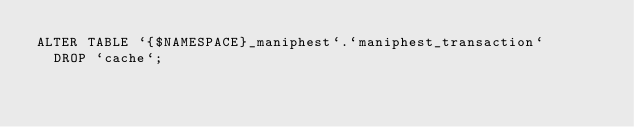<code> <loc_0><loc_0><loc_500><loc_500><_SQL_>ALTER TABLE `{$NAMESPACE}_maniphest`.`maniphest_transaction`
  DROP `cache`;
</code> 